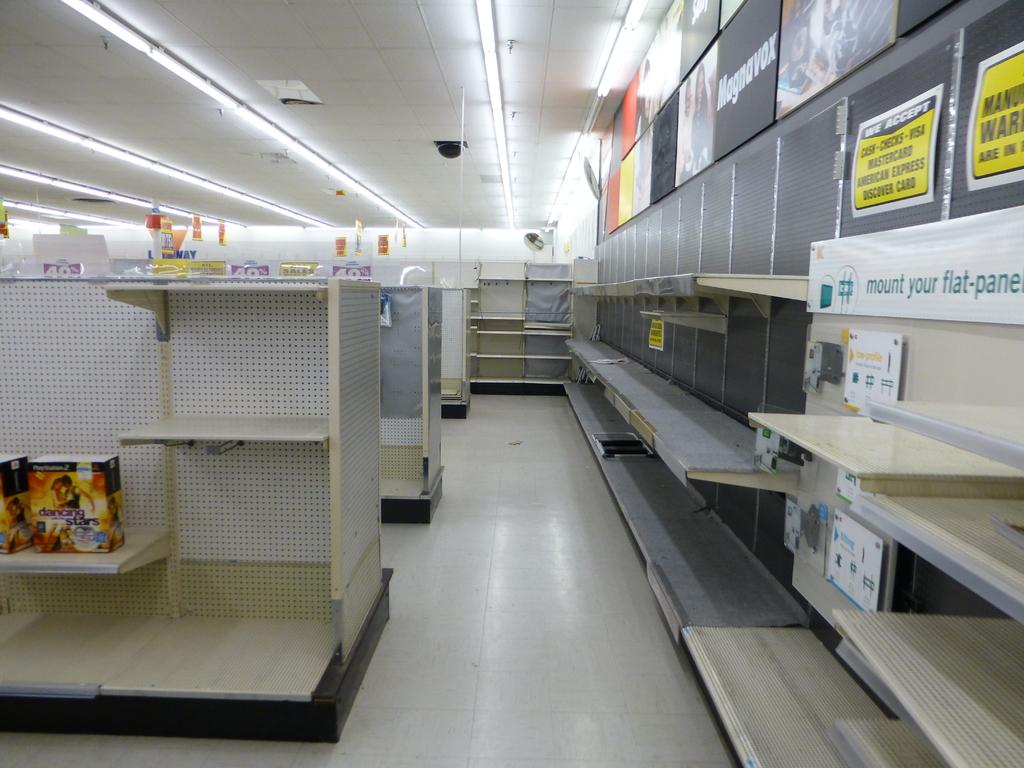<image>
Present a compact description of the photo's key features. the word checks that is on a sign 